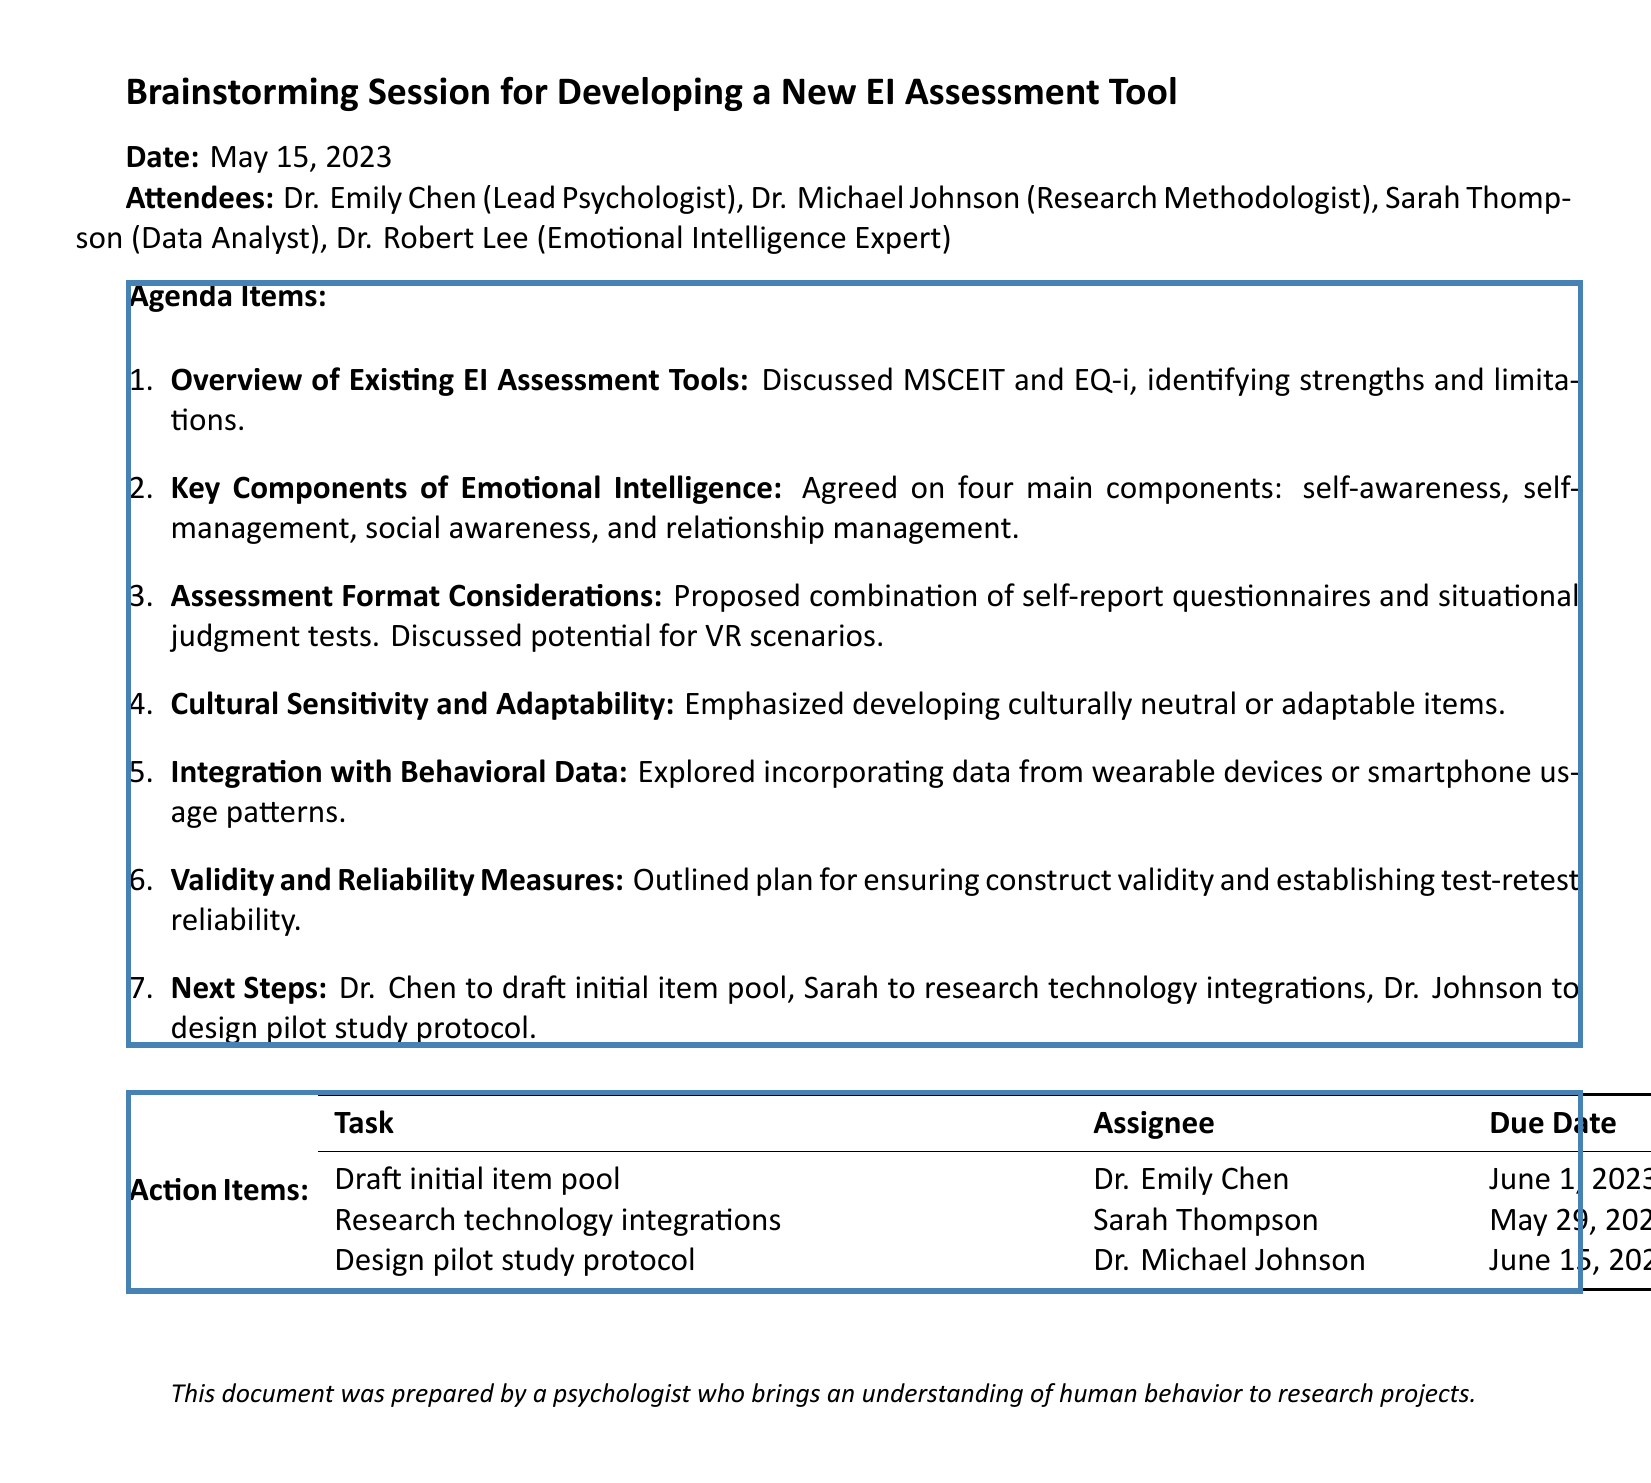What was the date of the meeting? The date of the meeting is clearly stated at the beginning of the document.
Answer: May 15, 2023 Who is the lead psychologist? The lead psychologist's name is mentioned in the list of attendees.
Answer: Dr. Emily Chen What are the four main components agreed upon for emotional intelligence? The main components are specified in the notes of the agenda items.
Answer: self-awareness, self-management, social awareness, relationship management What format was proposed for the assessment? The assessment format is discussed in one of the agenda items, specifying the combination used.
Answer: self-report questionnaires and situational judgment tests What is the due date for drafting the initial item pool? The due date for this action item is listed in the action items section.
Answer: June 1, 2023 What aspect of the assessment emphasized cultural considerations? This consideration is highlighted in the agenda items related to cultural sensitivity.
Answer: Cultural Sensitivity and Adaptability Who is responsible for researching technology integrations? The assignee for this task is explicitly mentioned in the action items table.
Answer: Sarah Thompson How many attendees were present at the meeting? The number of attendees can be counted from the list provided in the document.
Answer: Four 